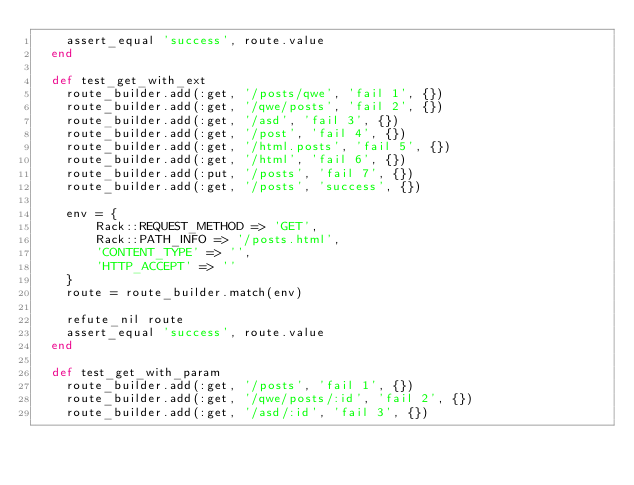<code> <loc_0><loc_0><loc_500><loc_500><_Ruby_>    assert_equal 'success', route.value
  end

  def test_get_with_ext
    route_builder.add(:get, '/posts/qwe', 'fail 1', {})
    route_builder.add(:get, '/qwe/posts', 'fail 2', {})
    route_builder.add(:get, '/asd', 'fail 3', {})
    route_builder.add(:get, '/post', 'fail 4', {})
    route_builder.add(:get, '/html.posts', 'fail 5', {})
    route_builder.add(:get, '/html', 'fail 6', {})
    route_builder.add(:put, '/posts', 'fail 7', {})
    route_builder.add(:get, '/posts', 'success', {})

    env = {
        Rack::REQUEST_METHOD => 'GET',
        Rack::PATH_INFO => '/posts.html',
        'CONTENT_TYPE' => '',
        'HTTP_ACCEPT' => ''
    }
    route = route_builder.match(env)

    refute_nil route
    assert_equal 'success', route.value
  end

  def test_get_with_param
    route_builder.add(:get, '/posts', 'fail 1', {})
    route_builder.add(:get, '/qwe/posts/:id', 'fail 2', {})
    route_builder.add(:get, '/asd/:id', 'fail 3', {})</code> 